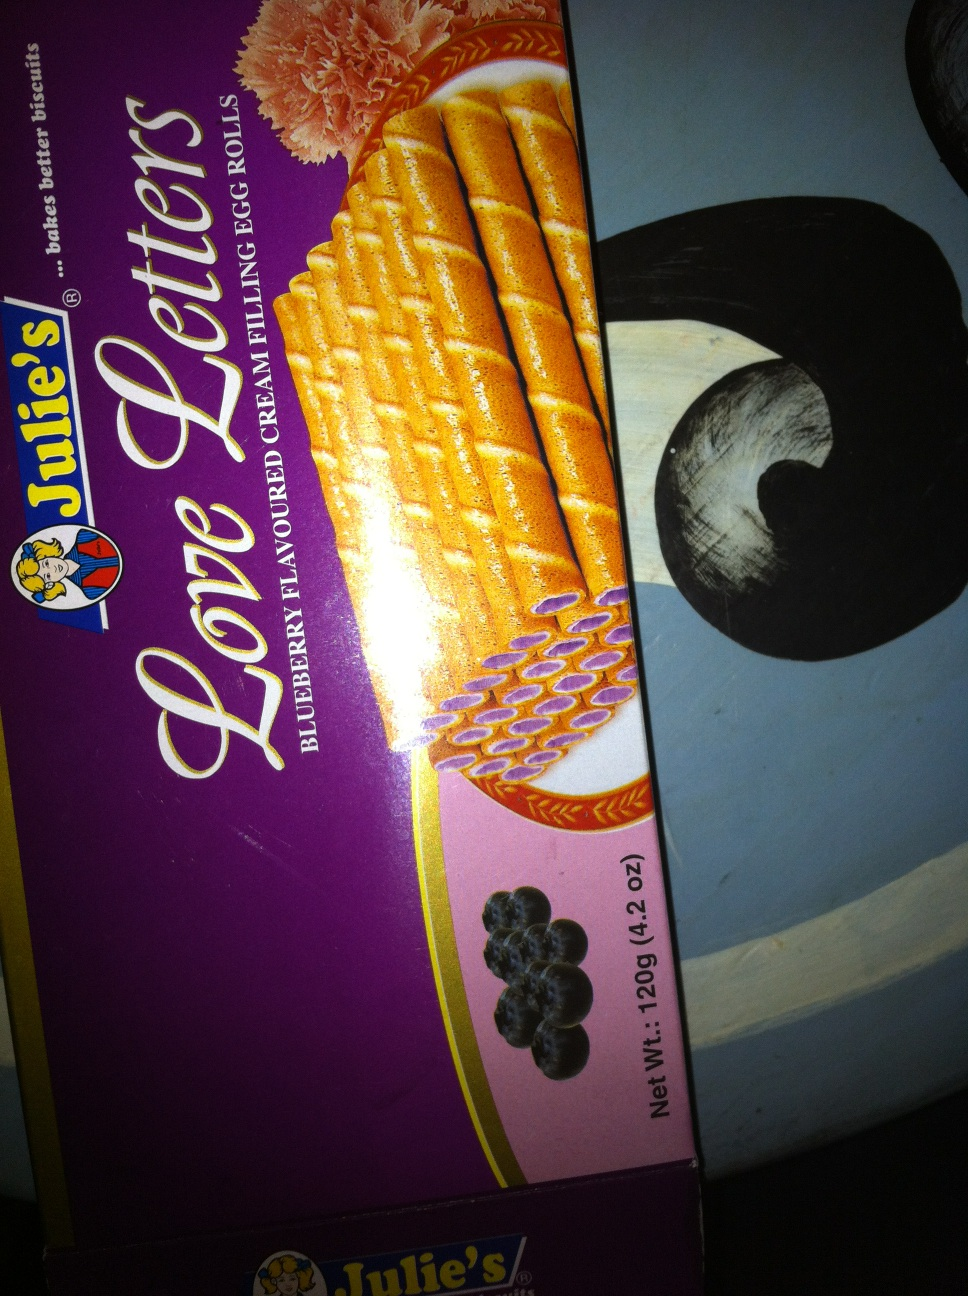Could you tell me more about the brand 'Julie's' visible on the box? Julie's is a well-known brand that specializes in a variety of baked goods and confectionery products. They are particularly popular for their biscuits and cookies, offering a range of flavors and types that appeal to diverse tastes. 